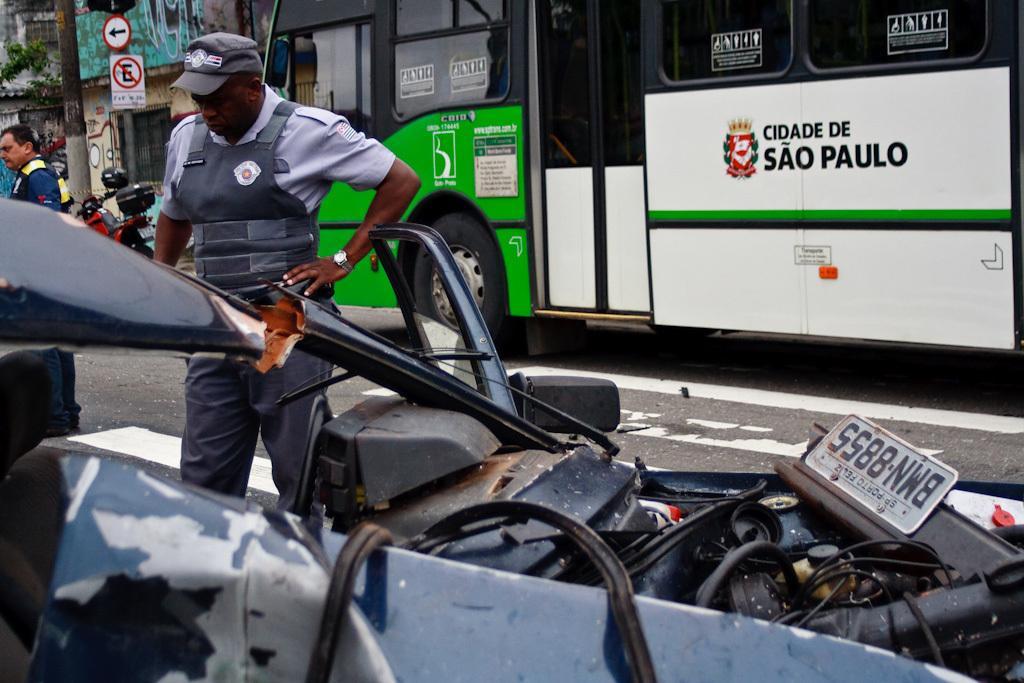In one or two sentences, can you explain what this image depicts? In this image I can see few vehicles and I can see two persons standing. In front the person is wearing gray color dress. In the background I can see few sign boards attached to the poles and I can also see few buildings. 